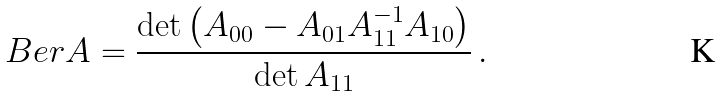<formula> <loc_0><loc_0><loc_500><loc_500>\ B e r A = \frac { \det \left ( A _ { 0 0 } - A _ { 0 1 } A _ { 1 1 } ^ { - 1 } A _ { 1 0 } \right ) } { \det A _ { 1 1 } } \, .</formula> 